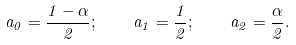<formula> <loc_0><loc_0><loc_500><loc_500>a _ { 0 } = { \frac { 1 - \alpha } { 2 } } ; \quad a _ { 1 } = { \frac { 1 } { 2 } } ; \quad a _ { 2 } = { \frac { \alpha } { 2 } } .</formula> 